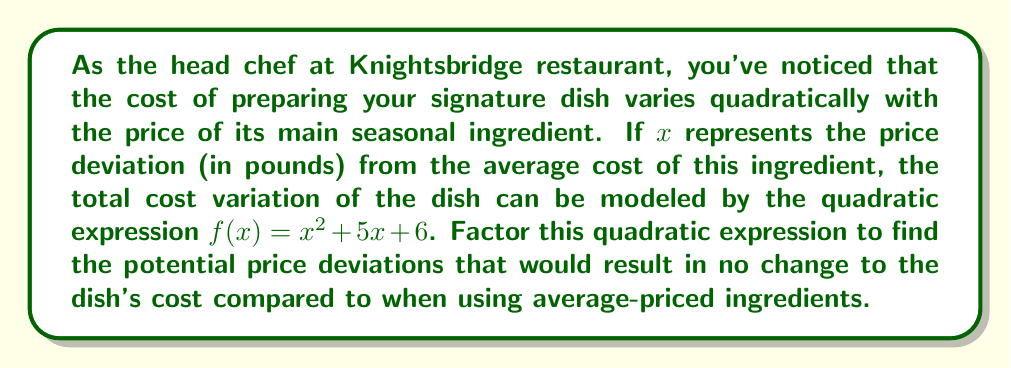Give your solution to this math problem. To solve this problem, we need to factor the quadratic expression $f(x) = x^2 + 5x + 6$ and find its roots. The roots of this quadratic expression will represent the price deviations that result in no change to the dish's cost.

Steps to factor the quadratic expression:

1) The quadratic expression is in the form $ax^2 + bx + c$, where $a=1$, $b=5$, and $c=6$.

2) We need to find two numbers that multiply to give $ac = 1 \times 6 = 6$ and add up to $b = 5$.

3) These numbers are 2 and 3, as $2 \times 3 = 6$ and $2 + 3 = 5$.

4) We can rewrite the middle term using these numbers:
   $f(x) = x^2 + 2x + 3x + 6$

5) Now we can factor by grouping:
   $f(x) = (x^2 + 2x) + (3x + 6)$
   $f(x) = x(x + 2) + 3(x + 2)$
   $f(x) = (x + 3)(x + 2)$

6) The factored form is $(x + 3)(x + 2)$. To find the roots, set each factor to zero and solve:

   $x + 3 = 0$ or $x + 2 = 0$
   $x = -3$ or $x = -2$

These roots represent the price deviations that would result in no change to the dish's cost compared to when using average-priced ingredients.
Answer: The factored form of the quadratic expression is $f(x) = (x + 3)(x + 2)$. The price deviations that would result in no change to the dish's cost are $x = -3$ and $x = -2$ pounds from the average ingredient price. 